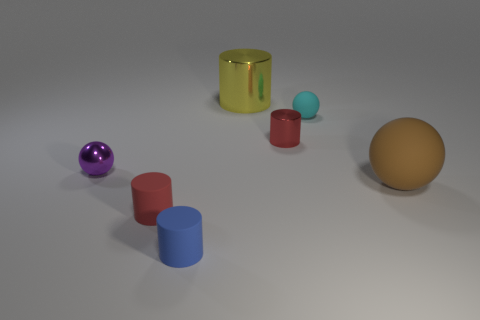Subtract all yellow cylinders. How many cylinders are left? 3 Subtract all purple spheres. How many spheres are left? 2 Subtract all balls. How many objects are left? 4 Subtract 4 cylinders. How many cylinders are left? 0 Subtract 0 green blocks. How many objects are left? 7 Subtract all yellow cylinders. Subtract all blue cubes. How many cylinders are left? 3 Subtract all purple cylinders. How many purple spheres are left? 1 Subtract all big things. Subtract all blue rubber cylinders. How many objects are left? 4 Add 6 cyan things. How many cyan things are left? 7 Add 1 gray rubber spheres. How many gray rubber spheres exist? 1 